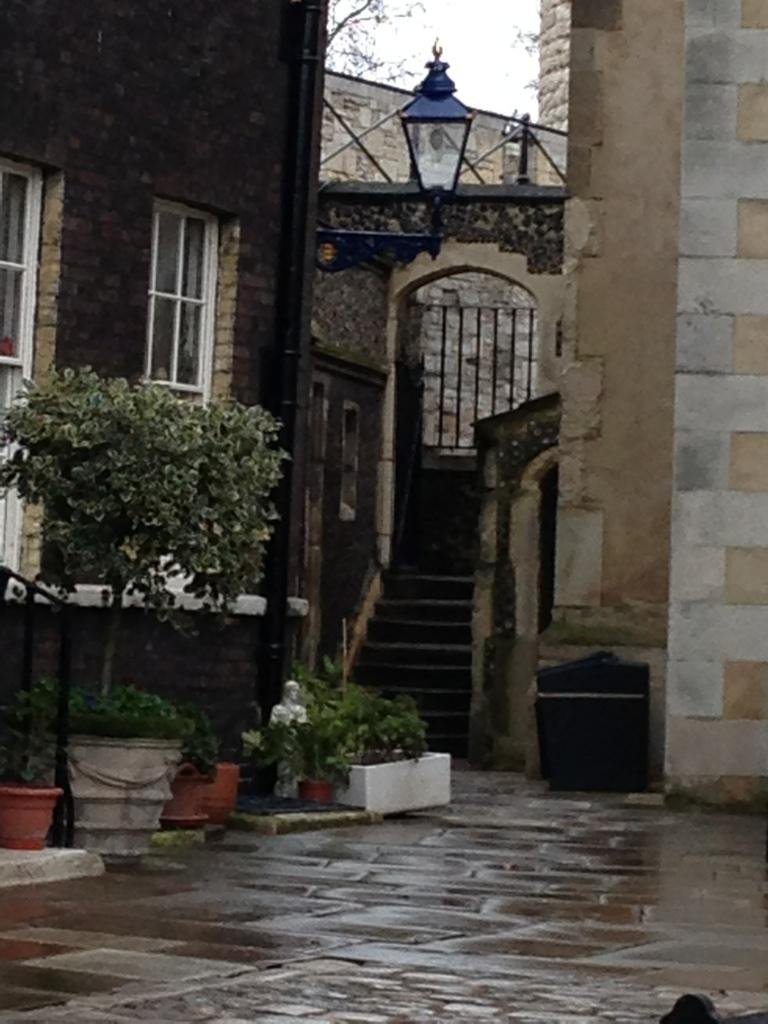What type of structures can be seen in the image? There are buildings in the image. What other elements are present in the image besides buildings? There are plants and trees in the image. Are there any man-made objects visible in the image? Yes, there are metal rods in the image. Can you see any blades of grass in the image? There is no specific mention of blades of grass in the provided facts, but since there are plants and trees in the image, it is possible that there may be blades of grass present. However, the facts do not explicitly confirm their presence. 